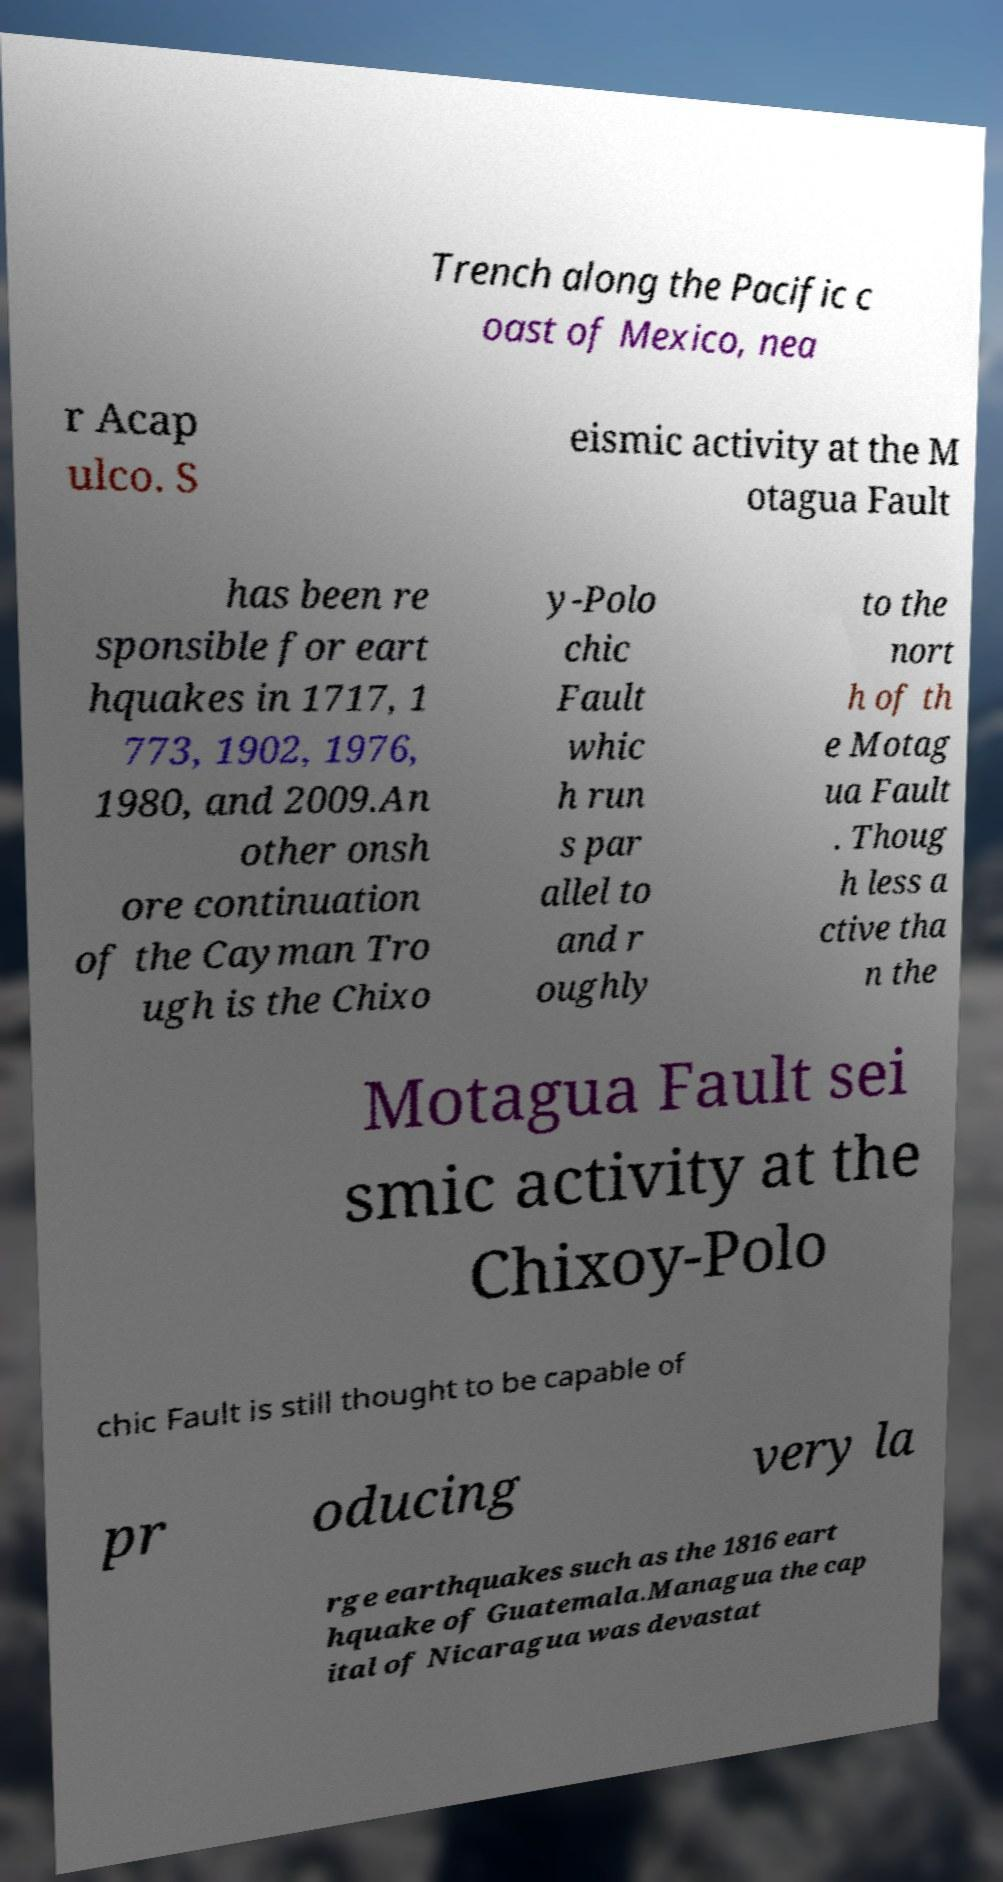Could you assist in decoding the text presented in this image and type it out clearly? Trench along the Pacific c oast of Mexico, nea r Acap ulco. S eismic activity at the M otagua Fault has been re sponsible for eart hquakes in 1717, 1 773, 1902, 1976, 1980, and 2009.An other onsh ore continuation of the Cayman Tro ugh is the Chixo y-Polo chic Fault whic h run s par allel to and r oughly to the nort h of th e Motag ua Fault . Thoug h less a ctive tha n the Motagua Fault sei smic activity at the Chixoy-Polo chic Fault is still thought to be capable of pr oducing very la rge earthquakes such as the 1816 eart hquake of Guatemala.Managua the cap ital of Nicaragua was devastat 